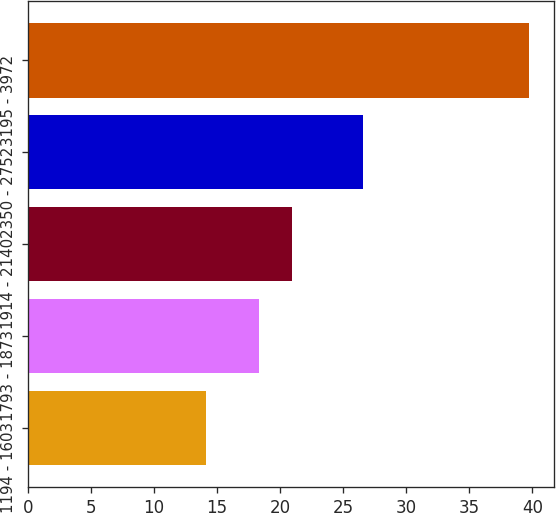Convert chart. <chart><loc_0><loc_0><loc_500><loc_500><bar_chart><fcel>1194 - 1603<fcel>1793 - 1873<fcel>1914 - 2140<fcel>2350 - 2752<fcel>3195 - 3972<nl><fcel>14.09<fcel>18.35<fcel>20.91<fcel>26.54<fcel>39.72<nl></chart> 